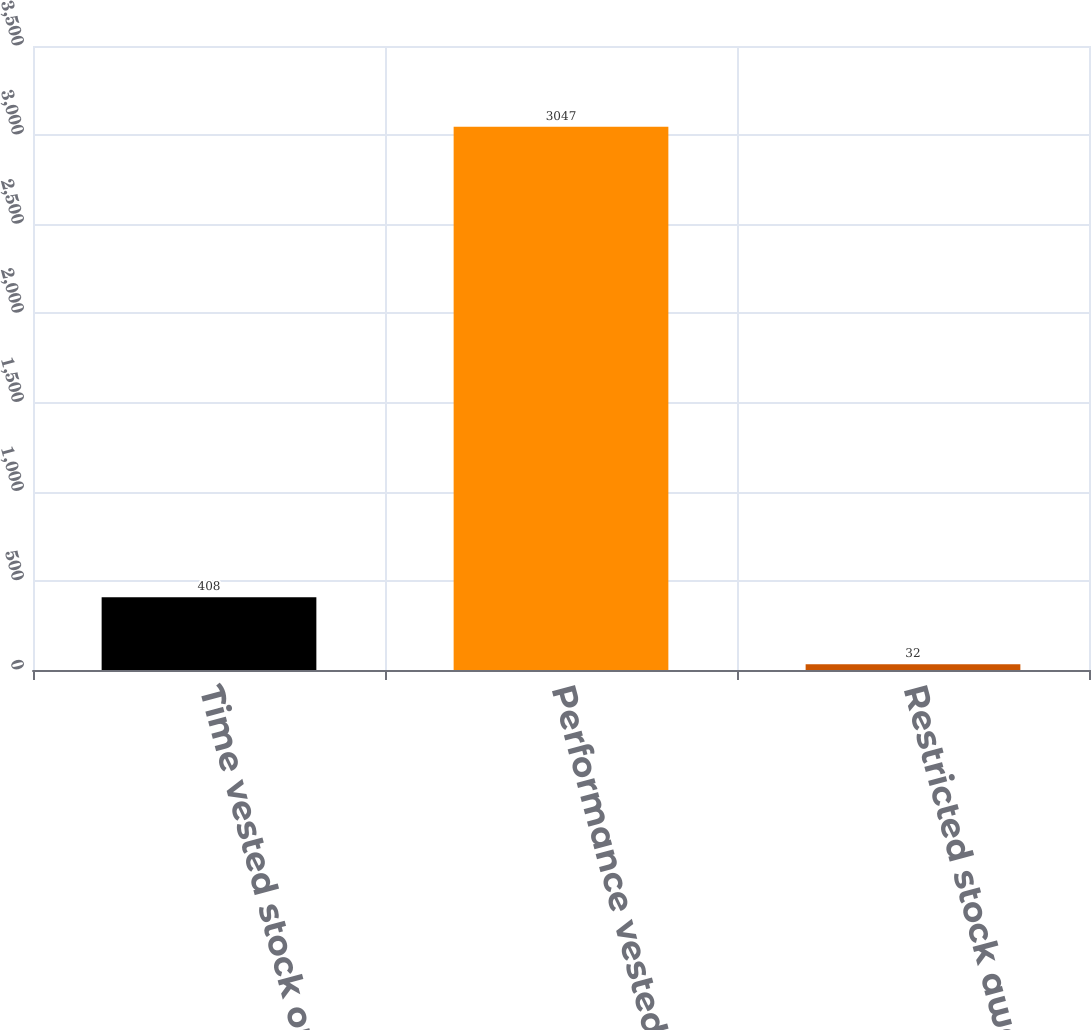Convert chart. <chart><loc_0><loc_0><loc_500><loc_500><bar_chart><fcel>Time vested stock options<fcel>Performance vested stock<fcel>Restricted stock award<nl><fcel>408<fcel>3047<fcel>32<nl></chart> 